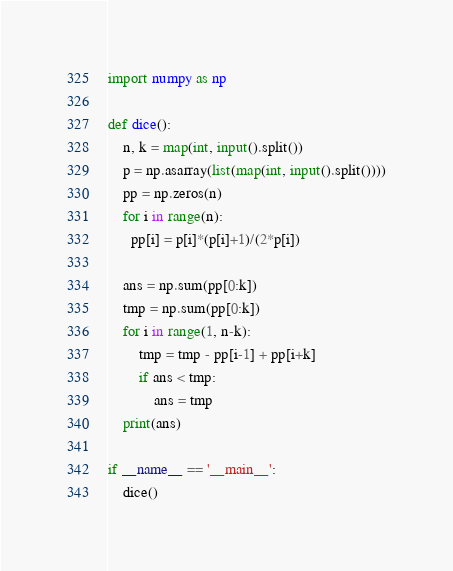<code> <loc_0><loc_0><loc_500><loc_500><_Python_>import numpy as np

def dice():
    n, k = map(int, input().split())
    p = np.asarray(list(map(int, input().split())))
    pp = np.zeros(n)
    for i in range(n):
      pp[i] = p[i]*(p[i]+1)/(2*p[i])

    ans = np.sum(pp[0:k])
    tmp = np.sum(pp[0:k])
    for i in range(1, n-k):
        tmp = tmp - pp[i-1] + pp[i+k]
        if ans < tmp:
            ans = tmp
    print(ans)

if __name__ == '__main__':
    dice()</code> 